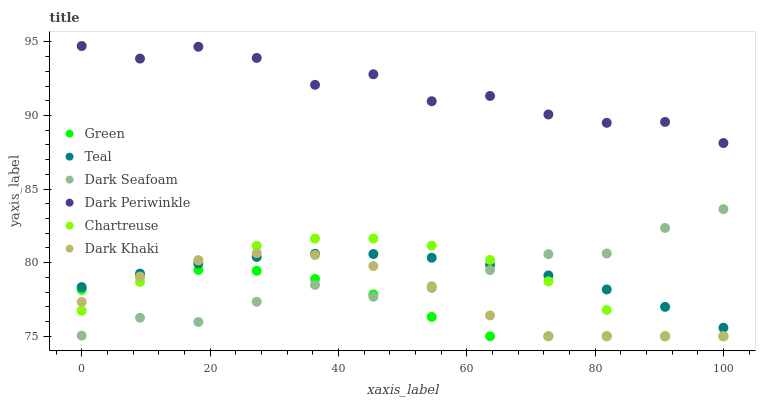Does Green have the minimum area under the curve?
Answer yes or no. Yes. Does Dark Periwinkle have the maximum area under the curve?
Answer yes or no. Yes. Does Dark Khaki have the minimum area under the curve?
Answer yes or no. No. Does Dark Khaki have the maximum area under the curve?
Answer yes or no. No. Is Teal the smoothest?
Answer yes or no. Yes. Is Dark Periwinkle the roughest?
Answer yes or no. Yes. Is Dark Khaki the smoothest?
Answer yes or no. No. Is Dark Khaki the roughest?
Answer yes or no. No. Does Dark Khaki have the lowest value?
Answer yes or no. Yes. Does Teal have the lowest value?
Answer yes or no. No. Does Dark Periwinkle have the highest value?
Answer yes or no. Yes. Does Dark Khaki have the highest value?
Answer yes or no. No. Is Green less than Dark Periwinkle?
Answer yes or no. Yes. Is Dark Periwinkle greater than Green?
Answer yes or no. Yes. Does Dark Khaki intersect Dark Seafoam?
Answer yes or no. Yes. Is Dark Khaki less than Dark Seafoam?
Answer yes or no. No. Is Dark Khaki greater than Dark Seafoam?
Answer yes or no. No. Does Green intersect Dark Periwinkle?
Answer yes or no. No. 